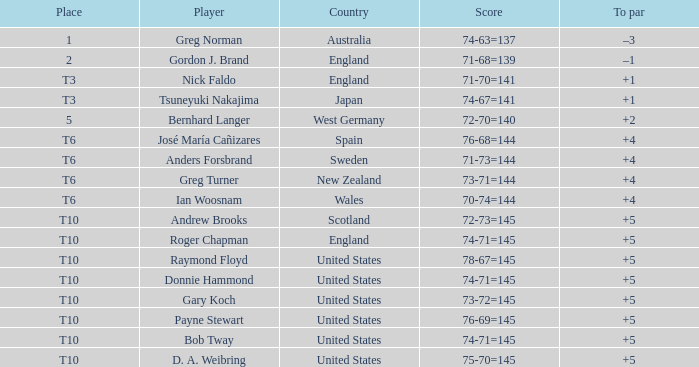What was united states' position when the participant was raymond floyd? T10. 